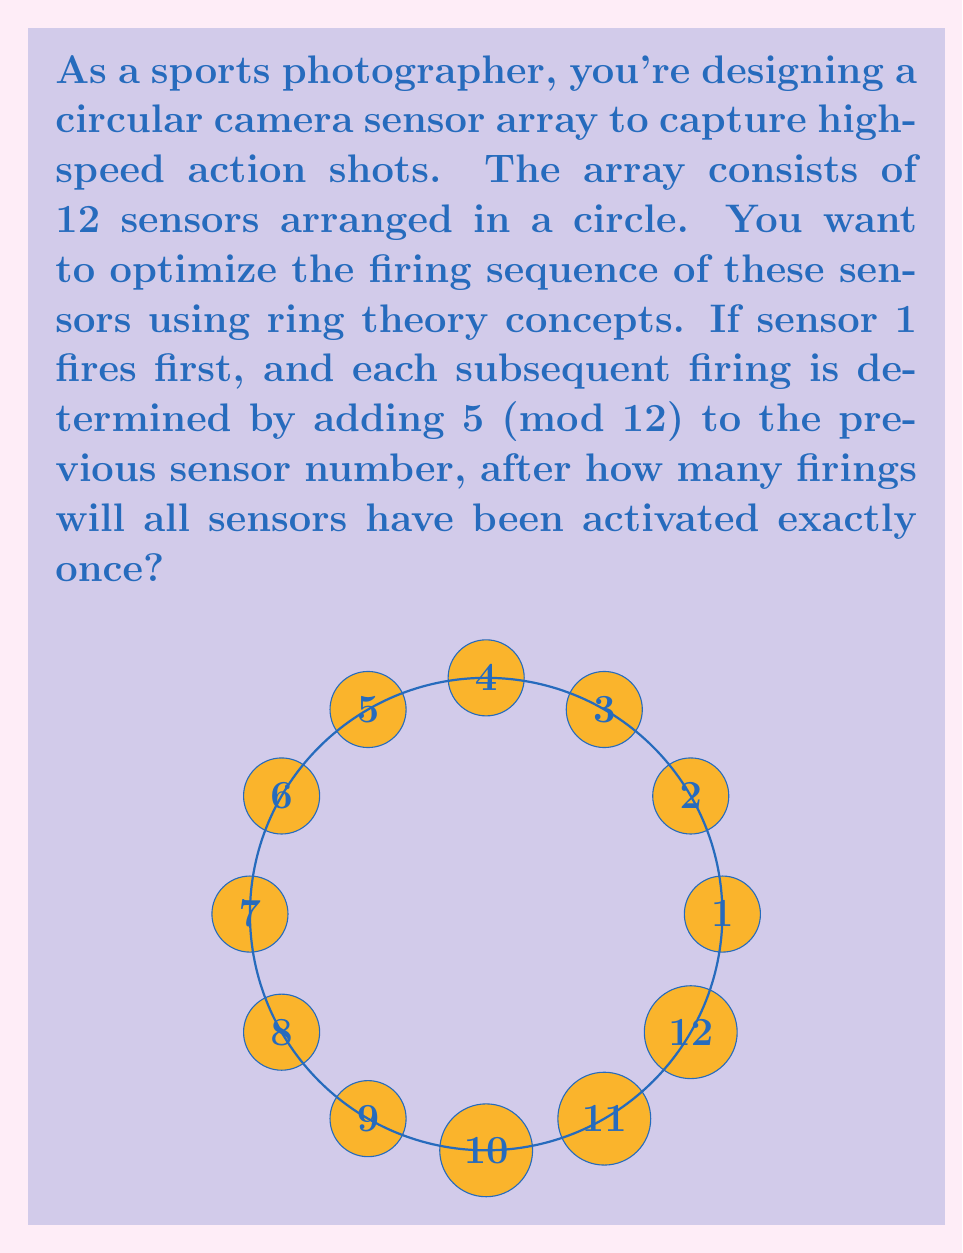Could you help me with this problem? Let's approach this step-by-step using concepts from ring theory:

1) We are working in the ring $\mathbb{Z}_{12}$ (integers modulo 12).

2) The firing sequence can be represented as a cyclic subgroup generated by 5 in $\mathbb{Z}_{12}$.

3) To find how many firings are needed, we need to find the order of 5 in $\mathbb{Z}_{12}$.

4) We can calculate this by finding the smallest positive integer $n$ such that:

   $5n \equiv 0 \pmod{12}$

5) Let's list out the multiples of 5 mod 12:
   $5 \cdot 1 \equiv 5 \pmod{12}$
   $5 \cdot 2 \equiv 10 \pmod{12}$
   $5 \cdot 3 \equiv 3 \pmod{12}$
   $5 \cdot 4 \equiv 8 \pmod{12}$
   $5 \cdot 5 \equiv 1 \pmod{12}$
   $5 \cdot 6 \equiv 6 \pmod{12}$
   $5 \cdot 7 \equiv 11 \pmod{12}$
   $5 \cdot 8 \equiv 4 \pmod{12}$
   $5 \cdot 9 \equiv 9 \pmod{12}$
   $5 \cdot 10 \equiv 2 \pmod{12}$
   $5 \cdot 11 \equiv 7 \pmod{12}$
   $5 \cdot 12 \equiv 0 \pmod{12}$

6) We see that it takes 12 steps to return to 0, which means all sensors have been activated once.

7) This is because $\gcd(5,12) = 1$, so 5 generates the entire group $\mathbb{Z}_{12}$.
Answer: 12 firings 